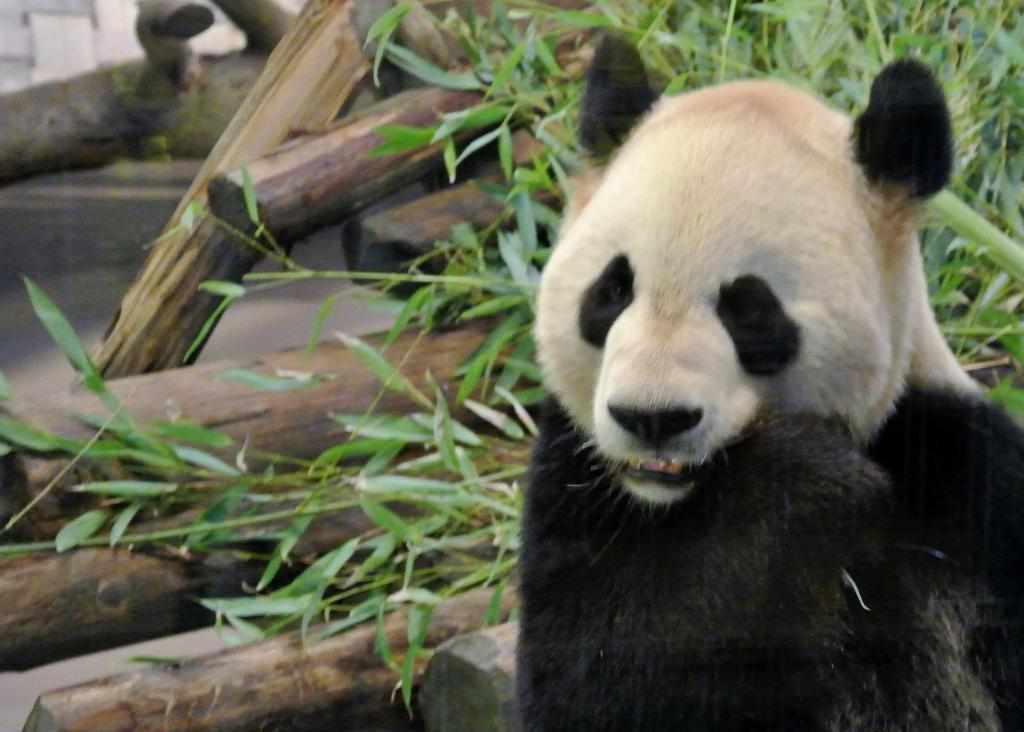What animal is featured in the image? There is a panda in the image. What can be seen in the background of the image? There are wood logs and plants in the background of the image. What type of vest is the panda wearing in the image? The panda is not wearing a vest in the image; it is a wild animal and does not wear clothing. 